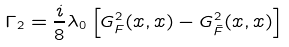<formula> <loc_0><loc_0><loc_500><loc_500>\Gamma _ { 2 } = \frac { i } { 8 } \lambda _ { 0 } \left [ G ^ { 2 } _ { F } ( x , x ) - G ^ { 2 } _ { \bar { F } } ( x , x ) \right ]</formula> 